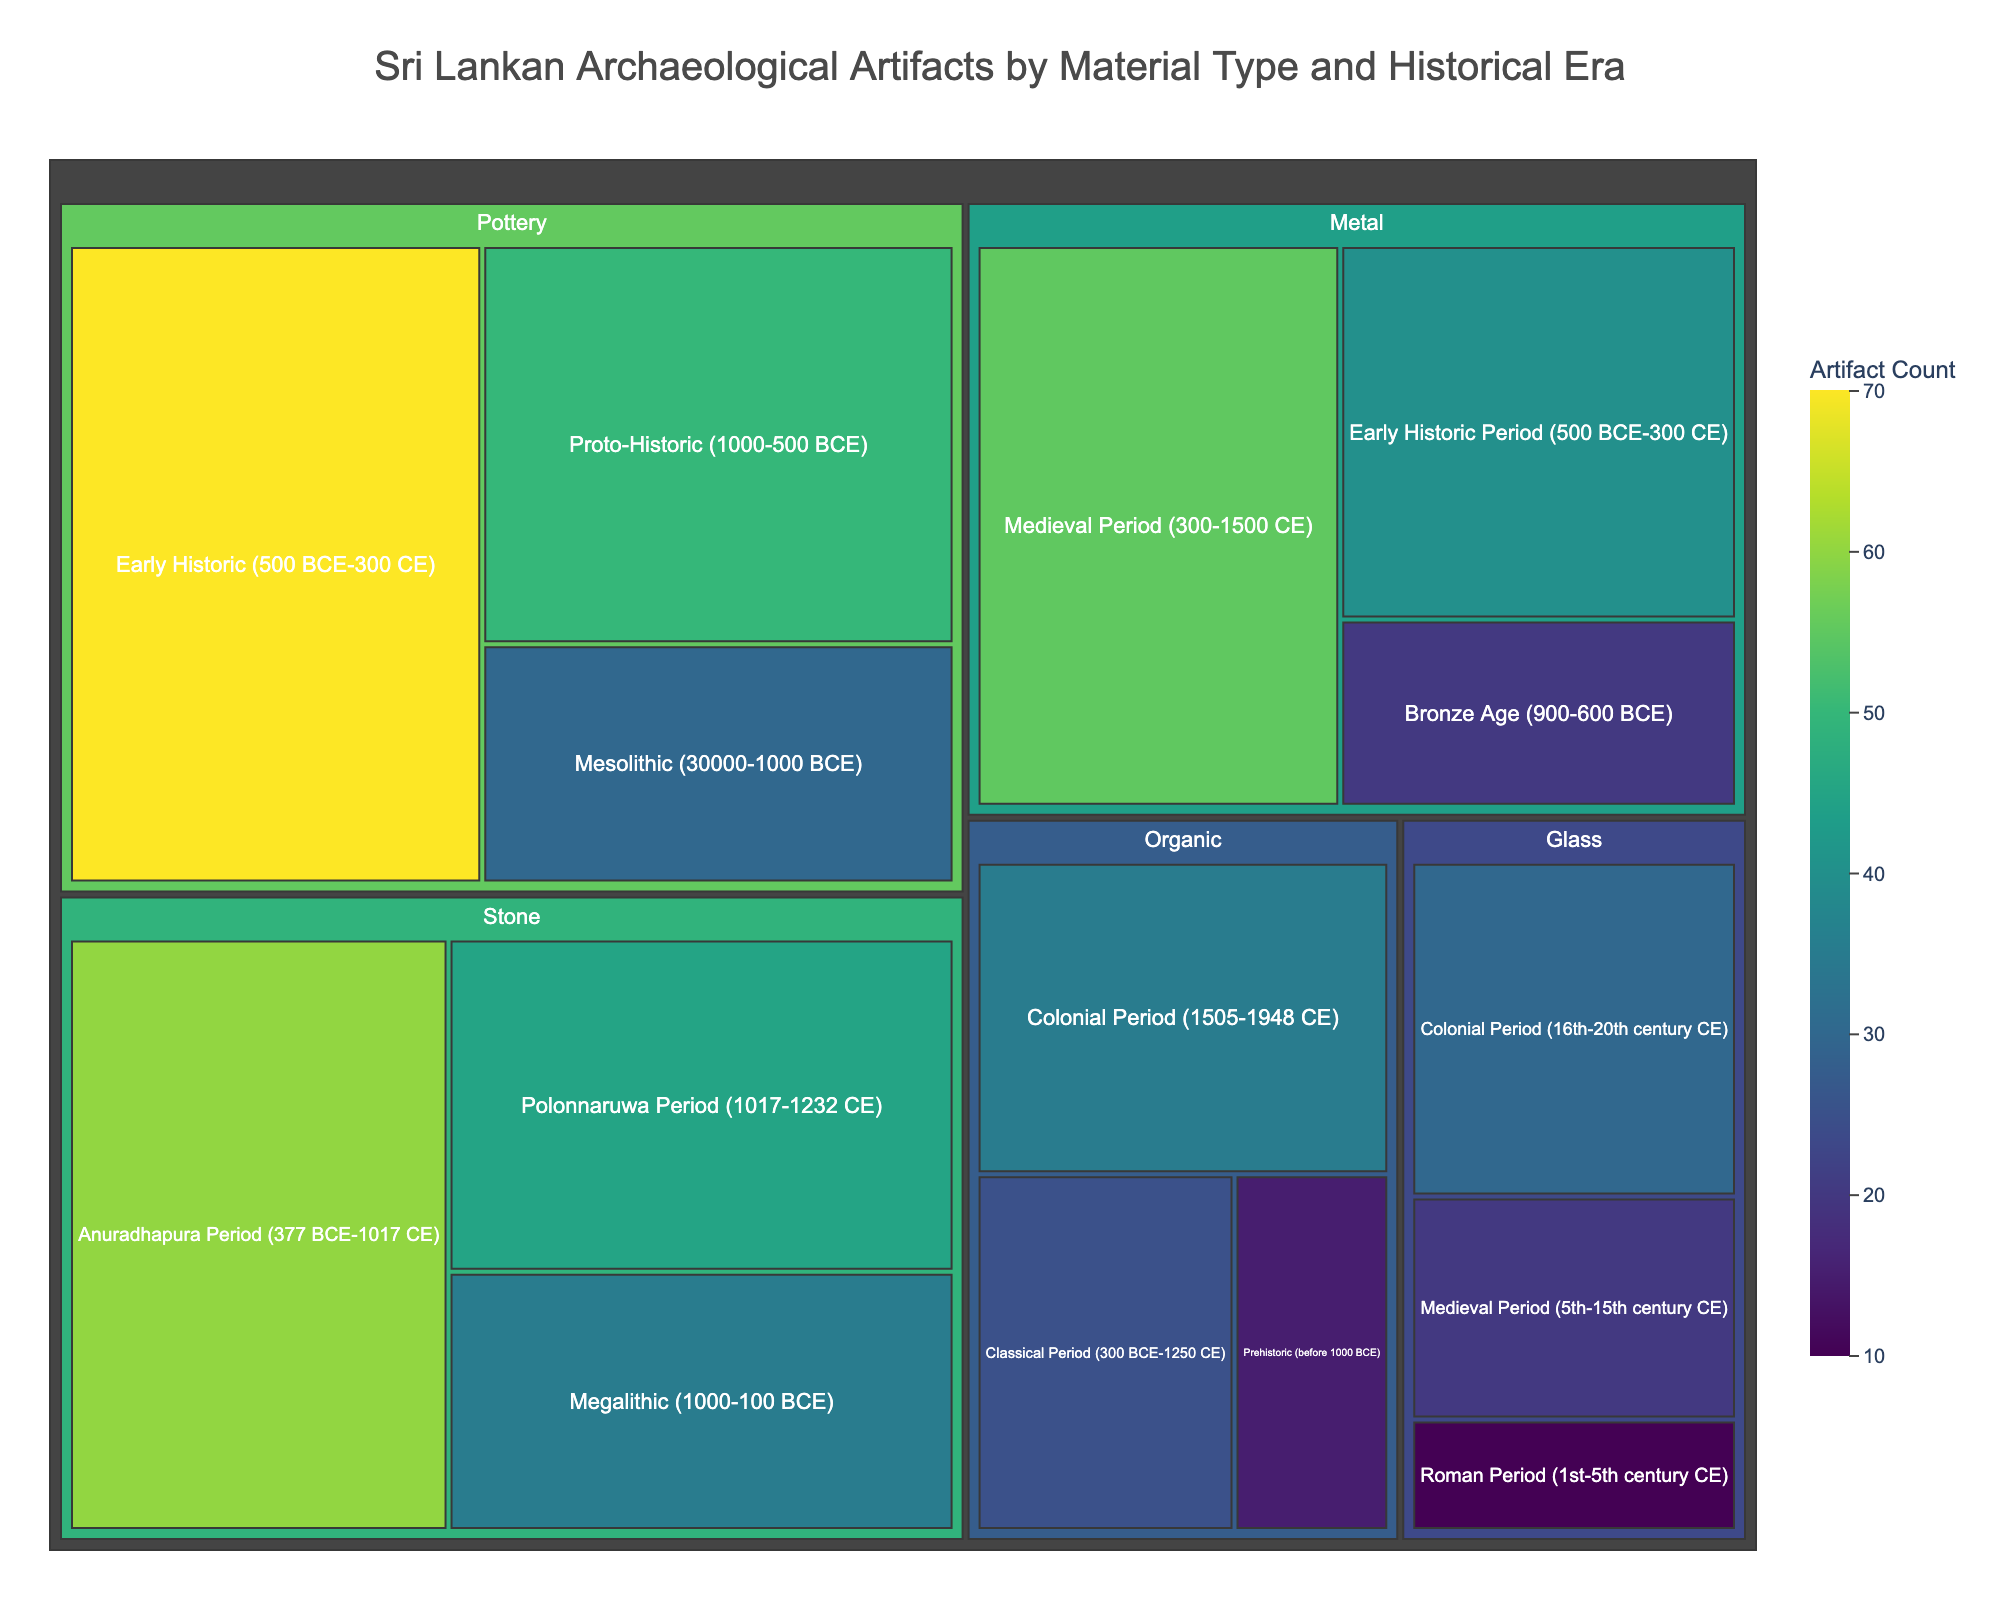Which material type has the highest quantity of artifacts in the Anuradhapura Period? Find the Anuradhapura Period and check which material has the largest value. The stone category has a value of 60, which is the highest among others.
Answer: Stone What is the total number of stone artifacts across all periods? Sum the quantities of stone artifacts in all historical periods: 35 (Megalithic) + 60 (Anuradhapura) + 45 (Polonnaruwa) = 140.
Answer: 140 Which historical era contains the highest count of glass artifacts? Identify the counts of glass artifacts in each era and compare them: 10 (Roman), 20 (Medieval), 30 (Colonial). The Colonial Period has the highest count with 30.
Answer: Colonial Period How many more pottery artifacts are found in the Early Historic Period compared to the Mesolithic Period? Look at the values: 70 (Early Historic) and 30 (Mesolithic). Subtract 30 from 70 to get the difference.
Answer: 40 Which material type has the least artifacts in the prehistoric period? Check the quantities for each material in the prehistoric period. Only organic artifacts are listed with a count of 15.
Answer: Organic Compare the quantity of metal artifacts in the Medieval Period to the Colonial Period. Which is greater and by how much? Check the values: 55 (Medieval) for metal, and compare it with 30 (Colonial) for glass. Metal in the Medieval Period has 25 more artifacts.
Answer: Metal, by 25 What is the total number of artifacts recorded in the Colonial Period across all categories? Sum the values of all artifacts in the Colonial Period: 35 (Organic) + 30 (Glass) = 65.
Answer: 65 Which historical era has more artifacts: the Proto-Historic or Early Historic Period? Compare the artifact numbers in these two periods: 50 (Proto-Historic) and 70 (Early Historic). The Early Historic Period has more artifacts.
Answer: Early Historic Period What is the combined count of metal artifacts from the Bronze Age and Early Historic Period? Sum the quantities of metal artifacts from these periods: 20 (Bronze Age) + 40 (Early Historic) = 60.
Answer: 60 In which historical era are the Bharhut-style railing art predominantly found under glass artifacts? There's no exact label "Bharhut-style railing art" but for glass artifacts, the highest value is found in the Colonial Period with 30.
Answer: Colonial Period 